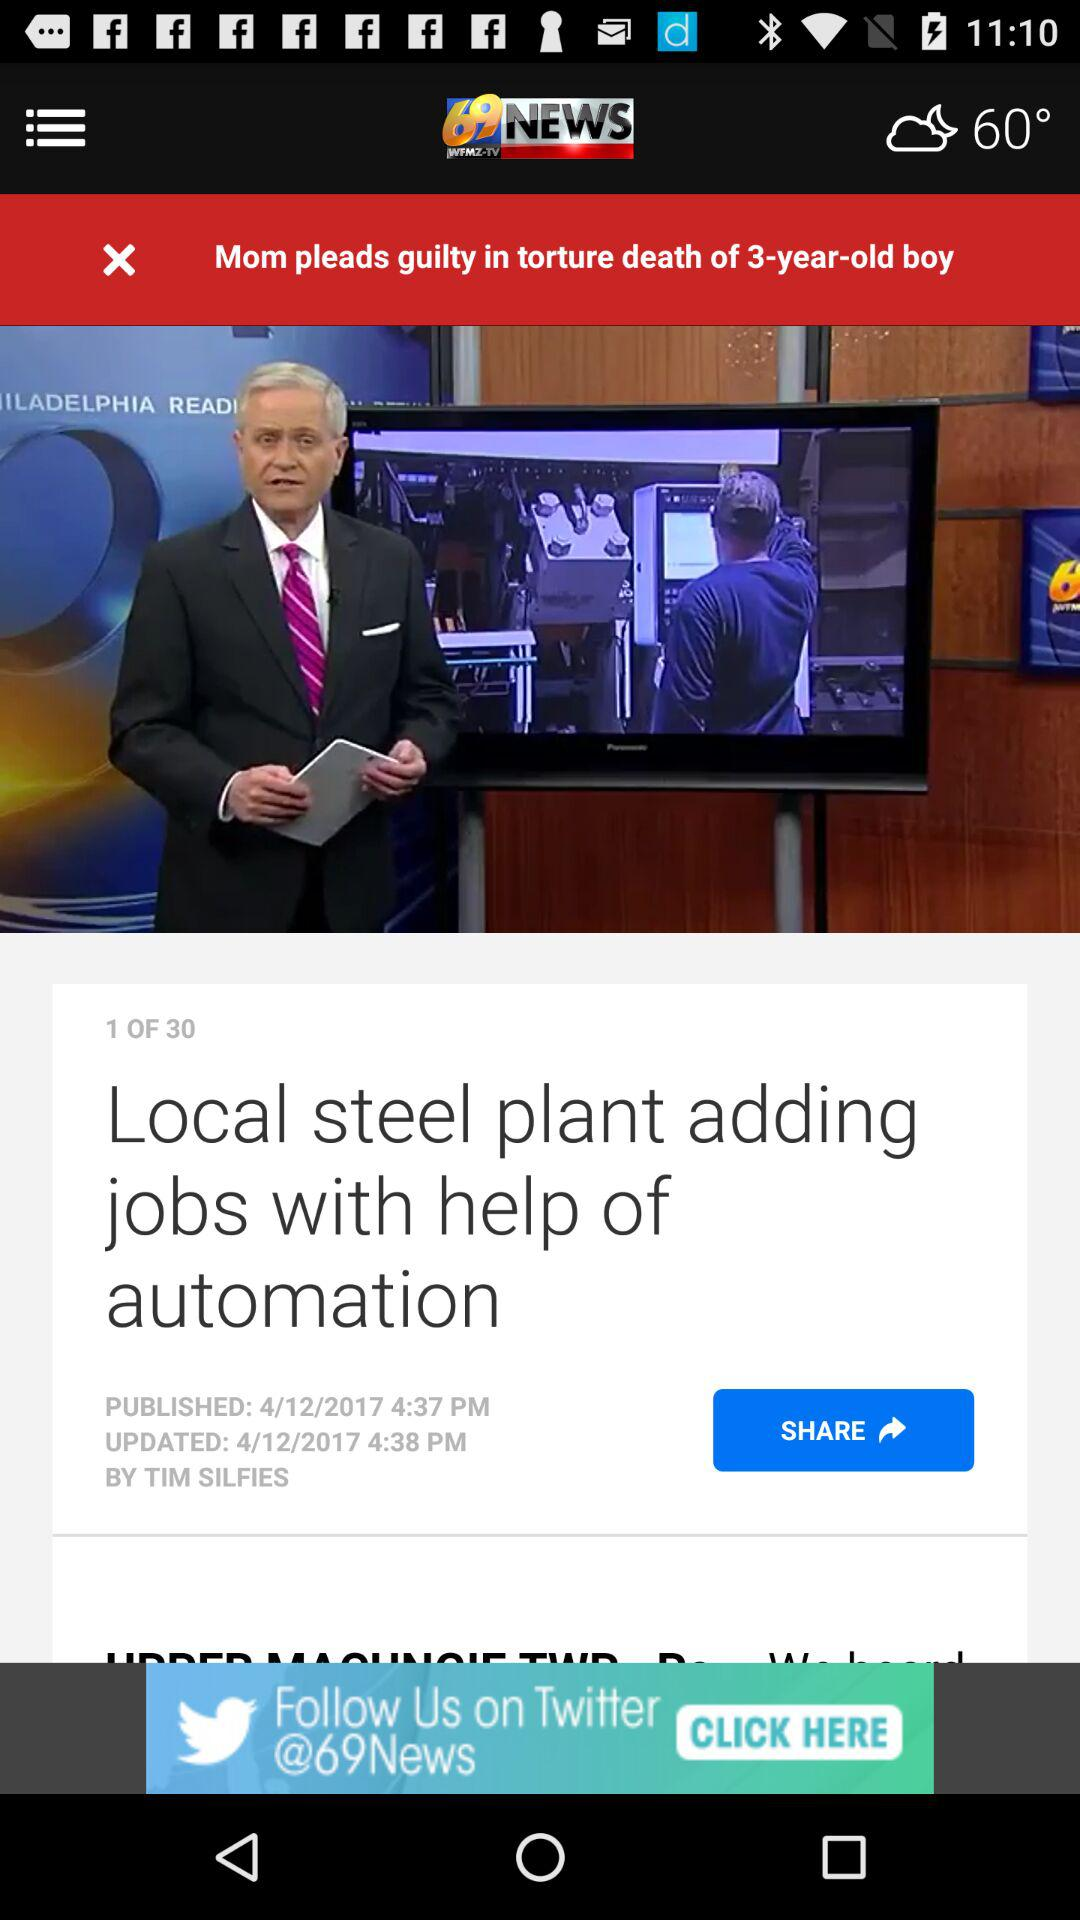What is the total number of news stories? The total number of news stories is 30. 